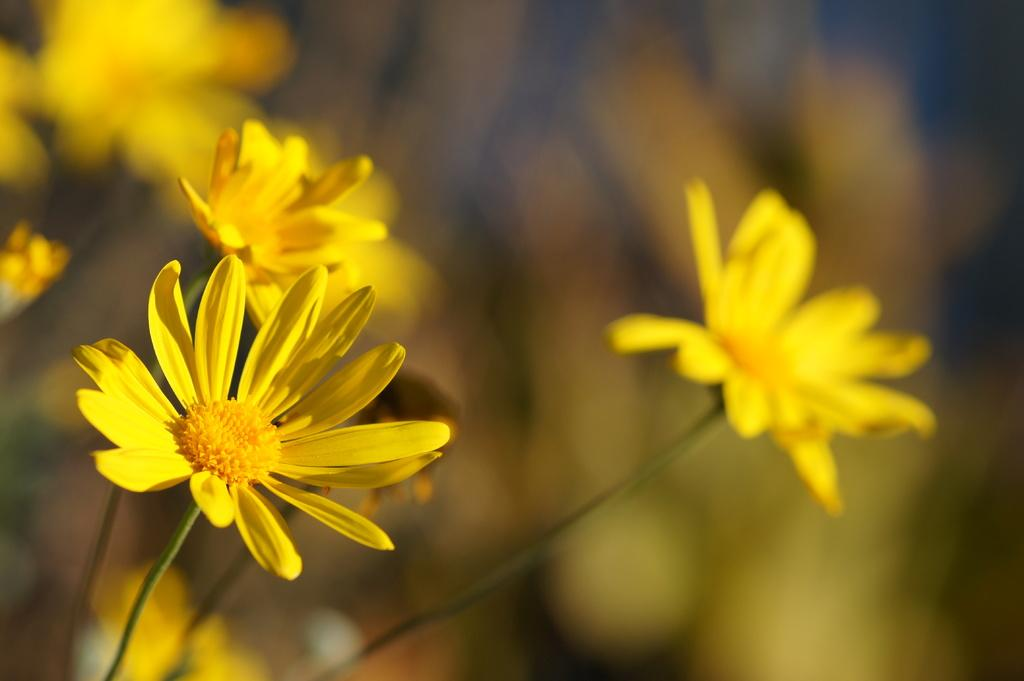What type of plants can be seen in the image? There are flowers in the image. Can you describe the structure of the flowers? The flowers have stems. What type of store can be seen in the image? There is no store present in the image; it features flowers with stems. 